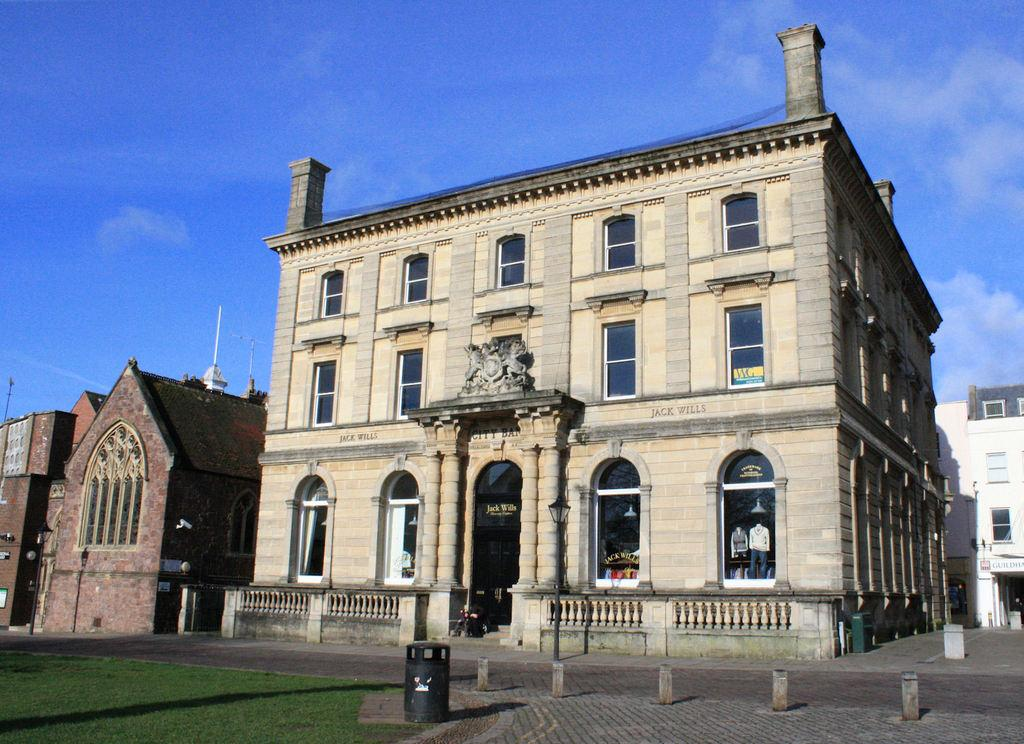What type of vegetation is in the foreground of the picture? There is grass in the foreground of the picture. What type of surface is also present in the foreground of the picture? There is a pavement in the foreground of the picture. What object can be seen in the foreground of the picture? There is a dustbin in the foreground of the picture. What type of structures are visible in the center of the picture? There are buildings in the center of the picture. What is visible at the top of the picture? The sky is visible at the top of the picture. What type of muscle can be seen flexing in the picture? There is no muscle visible in the picture; it features grass, pavement, a dustbin, buildings, and the sky. What type of songs are being sung by the buildings in the picture? Buildings do not sing songs, so this question cannot be answered based on the information provided. 